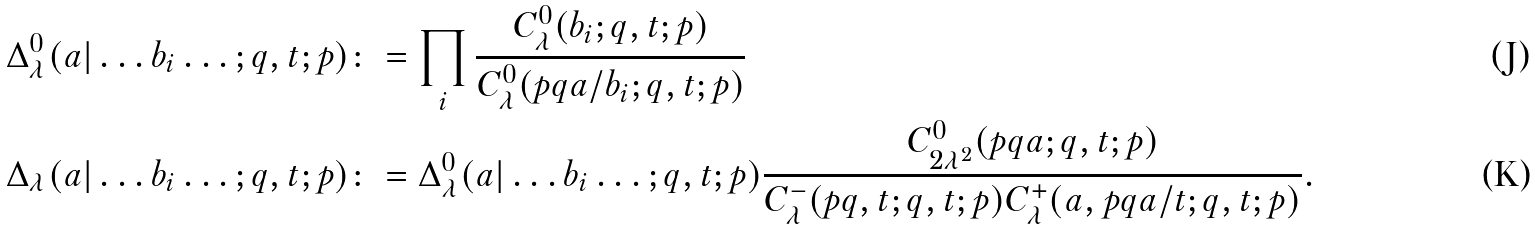Convert formula to latex. <formula><loc_0><loc_0><loc_500><loc_500>\Delta ^ { 0 } _ { \lambda } ( a | \dots b _ { i } \dots ; q , t ; p ) & \colon = \prod _ { i } \frac { C ^ { 0 } _ { \lambda } ( b _ { i } ; q , t ; p ) } { C ^ { 0 } _ { \lambda } ( p q a / b _ { i } ; q , t ; p ) } \\ \Delta _ { \lambda } ( a | \dots b _ { i } \dots ; q , t ; p ) & \colon = \Delta ^ { 0 } _ { \lambda } ( a | \dots b _ { i } \dots ; q , t ; p ) \frac { C ^ { 0 } _ { 2 \lambda ^ { 2 } } ( p q a ; q , t ; p ) } { C ^ { - } _ { \lambda } ( p q , t ; q , t ; p ) C ^ { + } _ { \lambda } ( a , p q a / t ; q , t ; p ) } .</formula> 